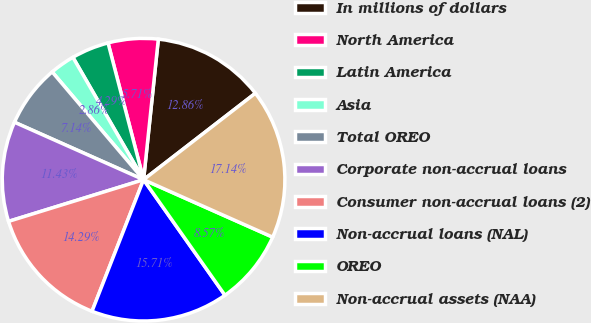<chart> <loc_0><loc_0><loc_500><loc_500><pie_chart><fcel>In millions of dollars<fcel>North America<fcel>Latin America<fcel>Asia<fcel>Total OREO<fcel>Corporate non-accrual loans<fcel>Consumer non-accrual loans (2)<fcel>Non-accrual loans (NAL)<fcel>OREO<fcel>Non-accrual assets (NAA)<nl><fcel>12.86%<fcel>5.71%<fcel>4.29%<fcel>2.86%<fcel>7.14%<fcel>11.43%<fcel>14.29%<fcel>15.71%<fcel>8.57%<fcel>17.14%<nl></chart> 